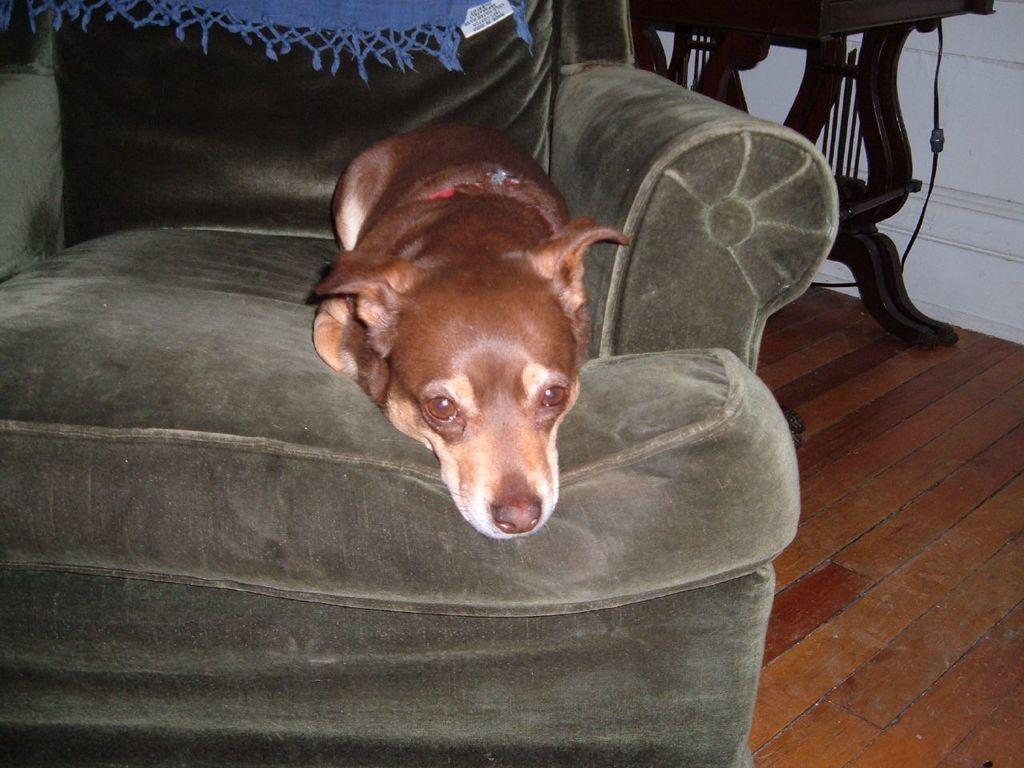Can you describe this image briefly? In this picture I can see a dog is sleeping on the sofa in the middle. 